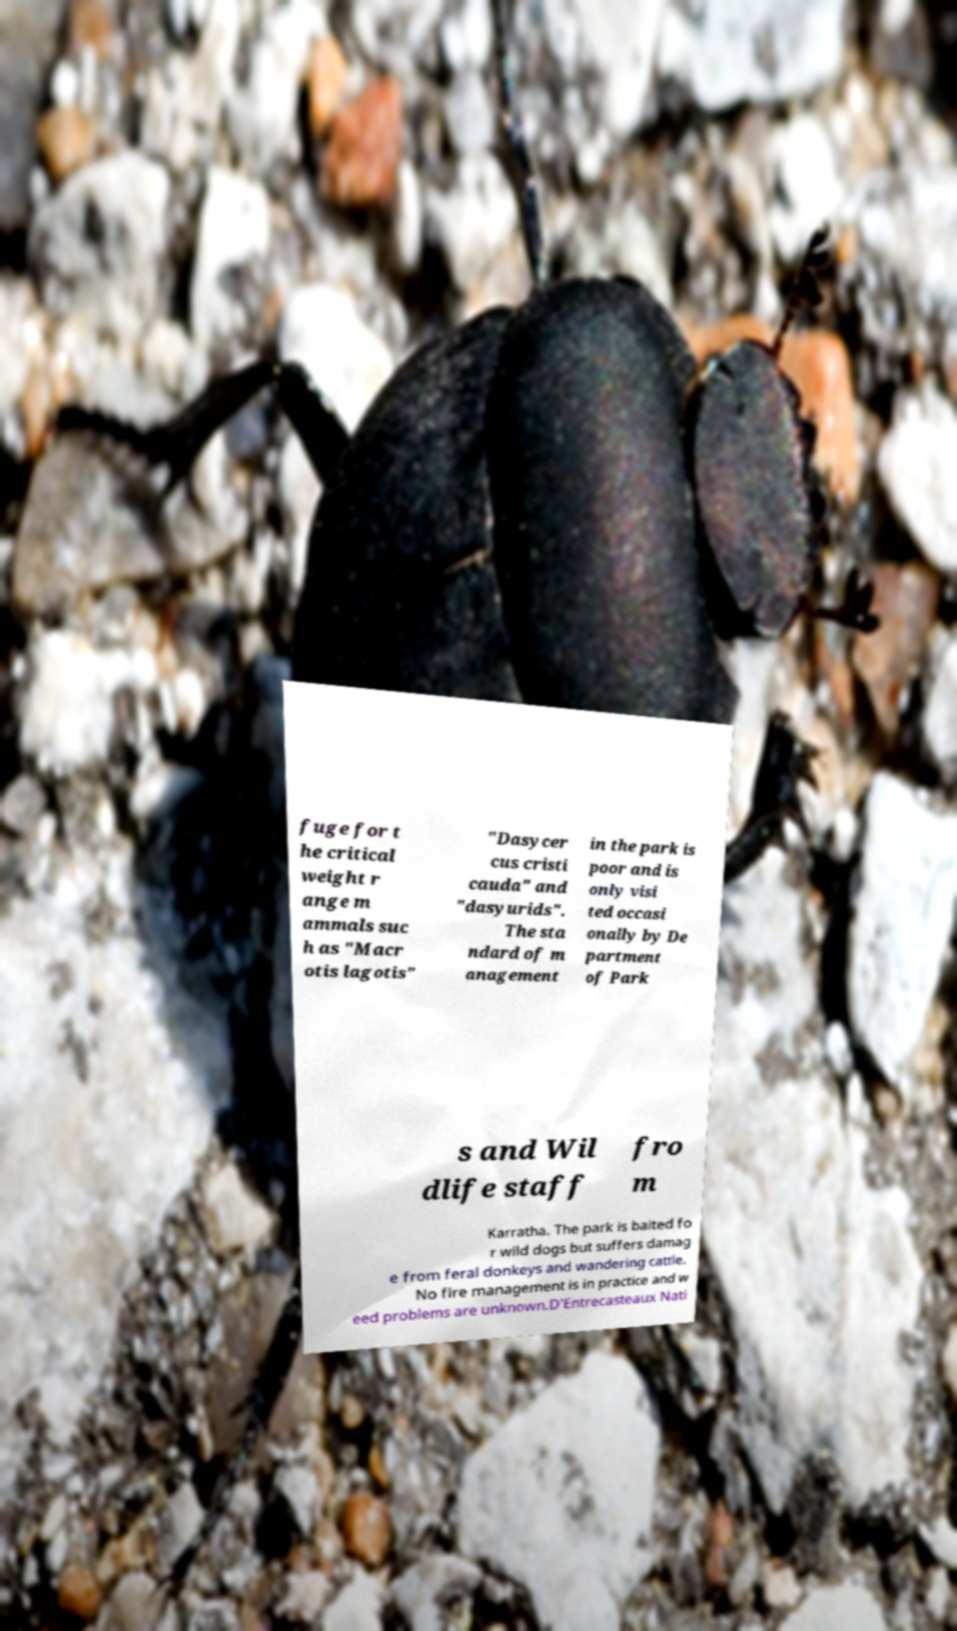I need the written content from this picture converted into text. Can you do that? fuge for t he critical weight r ange m ammals suc h as "Macr otis lagotis" "Dasycer cus cristi cauda" and "dasyurids". The sta ndard of m anagement in the park is poor and is only visi ted occasi onally by De partment of Park s and Wil dlife staff fro m Karratha. The park is baited fo r wild dogs but suffers damag e from feral donkeys and wandering cattle. No fire management is in practice and w eed problems are unknown.D'Entrecasteaux Nati 